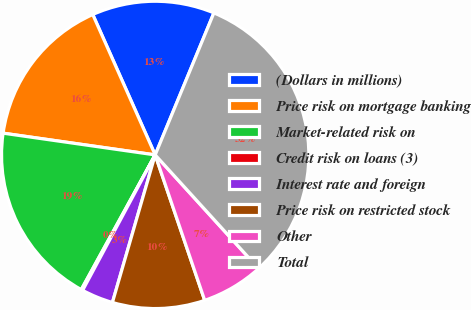<chart> <loc_0><loc_0><loc_500><loc_500><pie_chart><fcel>(Dollars in millions)<fcel>Price risk on mortgage banking<fcel>Market-related risk on<fcel>Credit risk on loans (3)<fcel>Interest rate and foreign<fcel>Price risk on restricted stock<fcel>Other<fcel>Total<nl><fcel>12.9%<fcel>16.08%<fcel>19.27%<fcel>0.16%<fcel>3.34%<fcel>9.71%<fcel>6.53%<fcel>32.01%<nl></chart> 